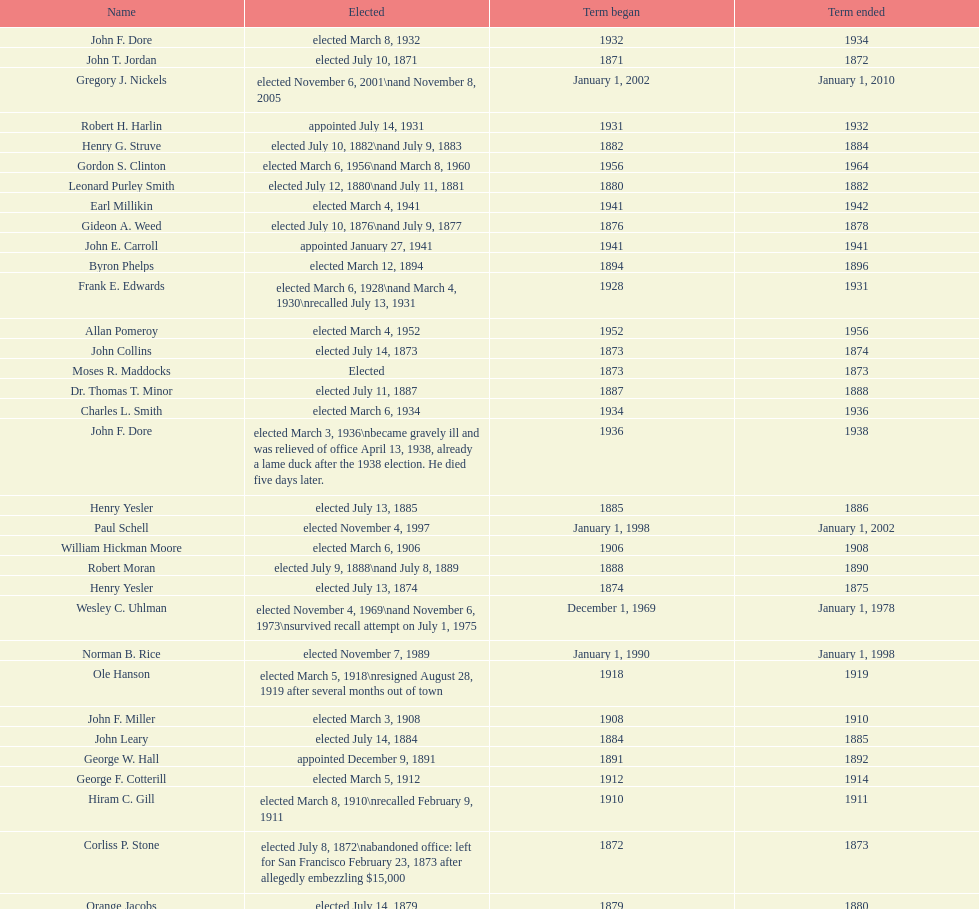Which mayor seattle, washington resigned after only three weeks in office in 1896? Frank D. Black. 